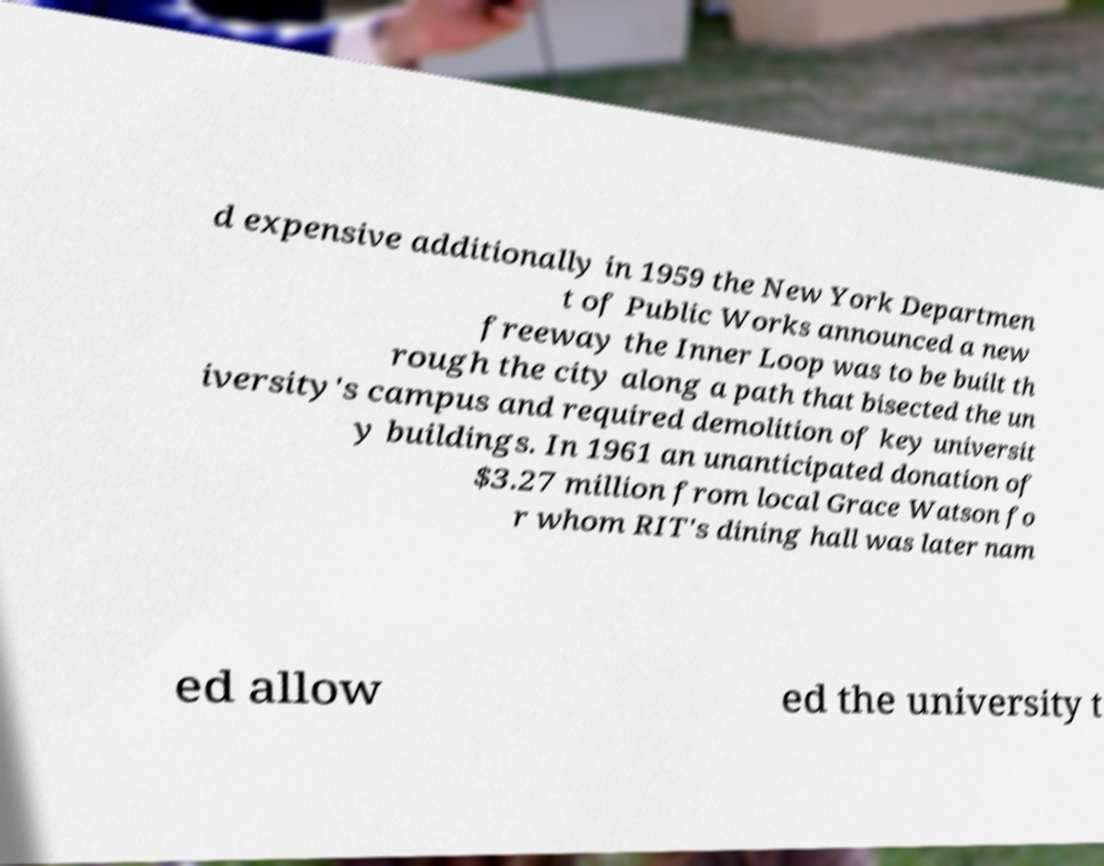Can you accurately transcribe the text from the provided image for me? d expensive additionally in 1959 the New York Departmen t of Public Works announced a new freeway the Inner Loop was to be built th rough the city along a path that bisected the un iversity's campus and required demolition of key universit y buildings. In 1961 an unanticipated donation of $3.27 million from local Grace Watson fo r whom RIT's dining hall was later nam ed allow ed the university t 